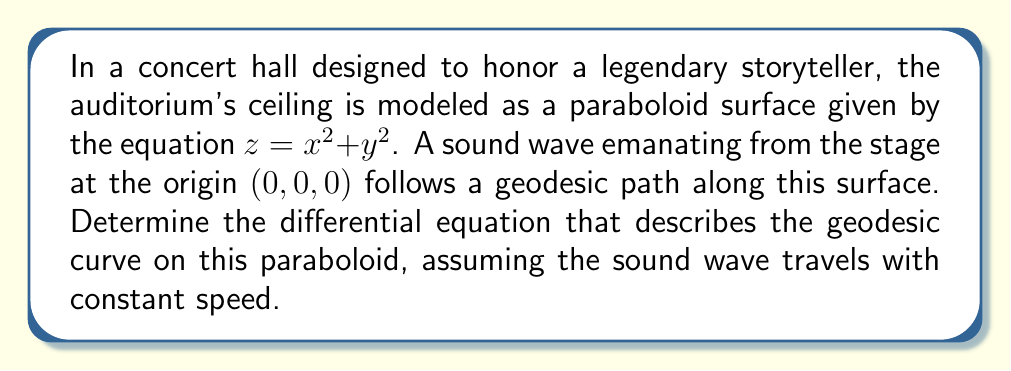Can you solve this math problem? Let's approach this step-by-step:

1) The surface is given by $z = x^2 + y^2$. We can parameterize this surface as:
   
   $\mathbf{r}(u,v) = (u, v, u^2 + v^2)$

2) To find the geodesic equation, we need to calculate the Christoffel symbols. First, let's compute the metric tensor:

   $g_{11} = 1 + 4u^2$
   $g_{12} = g_{21} = 4uv$
   $g_{22} = 1 + 4v^2$

3) The inverse metric tensor is:

   $g^{11} = \frac{1+4v^2}{(1+4u^2)(1+4v^2)-16u^2v^2}$
   $g^{12} = g^{21} = \frac{-4uv}{(1+4u^2)(1+4v^2)-16u^2v^2}$
   $g^{22} = \frac{1+4u^2}{(1+4u^2)(1+4v^2)-16u^2v^2}$

4) Now, we can calculate the Christoffel symbols:

   $\Gamma^1_{11} = \frac{4u}{1+4u^2+4v^2}$
   $\Gamma^1_{12} = \Gamma^1_{21} = \frac{2v}{1+4u^2+4v^2}$
   $\Gamma^1_{22} = \frac{-4u}{1+4u^2+4v^2}$
   
   $\Gamma^2_{11} = \frac{-4v}{1+4u^2+4v^2}$
   $\Gamma^2_{12} = \Gamma^2_{21} = \frac{2u}{1+4u^2+4v^2}$
   $\Gamma^2_{22} = \frac{4v}{1+4u^2+4v^2}$

5) The geodesic equations are:

   $\frac{d^2u}{ds^2} + \Gamma^1_{11}(\frac{du}{ds})^2 + 2\Gamma^1_{12}\frac{du}{ds}\frac{dv}{ds} + \Gamma^1_{22}(\frac{dv}{ds})^2 = 0$
   
   $\frac{d^2v}{ds^2} + \Gamma^2_{11}(\frac{du}{ds})^2 + 2\Gamma^2_{12}\frac{du}{ds}\frac{dv}{ds} + \Gamma^2_{22}(\frac{dv}{ds})^2 = 0$

6) Substituting the Christoffel symbols:

   $\frac{d^2u}{ds^2} + \frac{4u}{1+4u^2+4v^2}(\frac{du}{ds})^2 + \frac{4v}{1+4u^2+4v^2}\frac{du}{ds}\frac{dv}{ds} - \frac{4u}{1+4u^2+4v^2}(\frac{dv}{ds})^2 = 0$
   
   $\frac{d^2v}{ds^2} - \frac{4v}{1+4u^2+4v^2}(\frac{du}{ds})^2 + \frac{4u}{1+4u^2+4v^2}\frac{du}{ds}\frac{dv}{ds} + \frac{4v}{1+4u^2+4v^2}(\frac{dv}{ds})^2 = 0$

These coupled differential equations describe the geodesic curve on the paraboloid surface.
Answer: $$\begin{cases}
\frac{d^2u}{ds^2} + \frac{4u}{1+4u^2+4v^2}(\frac{du}{ds})^2 + \frac{4v}{1+4u^2+4v^2}\frac{du}{ds}\frac{dv}{ds} - \frac{4u}{1+4u^2+4v^2}(\frac{dv}{ds})^2 = 0 \\
\frac{d^2v}{ds^2} - \frac{4v}{1+4u^2+4v^2}(\frac{du}{ds})^2 + \frac{4u}{1+4u^2+4v^2}\frac{du}{ds}\frac{dv}{ds} + \frac{4v}{1+4u^2+4v^2}(\frac{dv}{ds})^2 = 0
\end{cases}$$ 